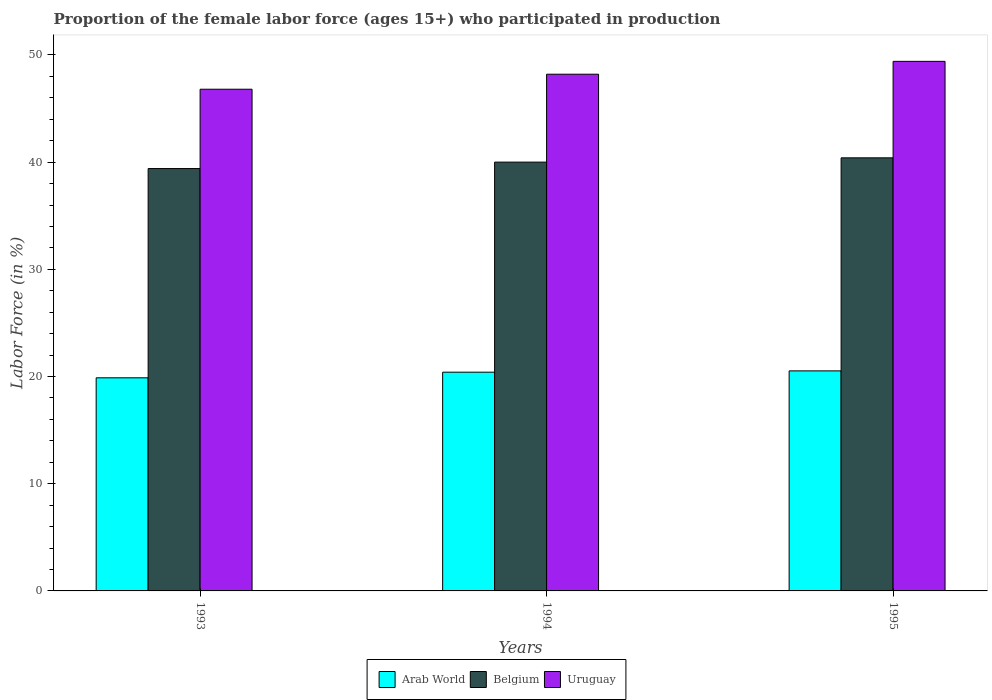Are the number of bars on each tick of the X-axis equal?
Provide a succinct answer. Yes. How many bars are there on the 2nd tick from the right?
Your response must be concise. 3. What is the proportion of the female labor force who participated in production in Uruguay in 1993?
Offer a terse response. 46.8. Across all years, what is the maximum proportion of the female labor force who participated in production in Uruguay?
Give a very brief answer. 49.4. Across all years, what is the minimum proportion of the female labor force who participated in production in Belgium?
Make the answer very short. 39.4. In which year was the proportion of the female labor force who participated in production in Belgium maximum?
Your response must be concise. 1995. In which year was the proportion of the female labor force who participated in production in Arab World minimum?
Offer a very short reply. 1993. What is the total proportion of the female labor force who participated in production in Arab World in the graph?
Your answer should be compact. 60.81. What is the difference between the proportion of the female labor force who participated in production in Arab World in 1994 and that in 1995?
Provide a succinct answer. -0.12. What is the difference between the proportion of the female labor force who participated in production in Arab World in 1993 and the proportion of the female labor force who participated in production in Belgium in 1994?
Provide a short and direct response. -20.12. What is the average proportion of the female labor force who participated in production in Arab World per year?
Provide a short and direct response. 20.27. In the year 1993, what is the difference between the proportion of the female labor force who participated in production in Uruguay and proportion of the female labor force who participated in production in Belgium?
Give a very brief answer. 7.4. In how many years, is the proportion of the female labor force who participated in production in Belgium greater than 48 %?
Provide a short and direct response. 0. What is the ratio of the proportion of the female labor force who participated in production in Arab World in 1994 to that in 1995?
Provide a short and direct response. 0.99. Is the proportion of the female labor force who participated in production in Arab World in 1993 less than that in 1994?
Offer a very short reply. Yes. What is the difference between the highest and the second highest proportion of the female labor force who participated in production in Belgium?
Make the answer very short. 0.4. What is the difference between the highest and the lowest proportion of the female labor force who participated in production in Uruguay?
Make the answer very short. 2.6. Is the sum of the proportion of the female labor force who participated in production in Belgium in 1994 and 1995 greater than the maximum proportion of the female labor force who participated in production in Arab World across all years?
Make the answer very short. Yes. What does the 3rd bar from the left in 1994 represents?
Your response must be concise. Uruguay. What does the 3rd bar from the right in 1995 represents?
Offer a very short reply. Arab World. Is it the case that in every year, the sum of the proportion of the female labor force who participated in production in Uruguay and proportion of the female labor force who participated in production in Arab World is greater than the proportion of the female labor force who participated in production in Belgium?
Keep it short and to the point. Yes. Are all the bars in the graph horizontal?
Your response must be concise. No. How many years are there in the graph?
Your answer should be very brief. 3. Are the values on the major ticks of Y-axis written in scientific E-notation?
Provide a succinct answer. No. Does the graph contain any zero values?
Provide a succinct answer. No. Does the graph contain grids?
Keep it short and to the point. No. How many legend labels are there?
Your answer should be compact. 3. How are the legend labels stacked?
Offer a very short reply. Horizontal. What is the title of the graph?
Keep it short and to the point. Proportion of the female labor force (ages 15+) who participated in production. Does "Sri Lanka" appear as one of the legend labels in the graph?
Offer a very short reply. No. What is the label or title of the X-axis?
Offer a very short reply. Years. What is the Labor Force (in %) of Arab World in 1993?
Keep it short and to the point. 19.88. What is the Labor Force (in %) of Belgium in 1993?
Your response must be concise. 39.4. What is the Labor Force (in %) in Uruguay in 1993?
Your answer should be very brief. 46.8. What is the Labor Force (in %) in Arab World in 1994?
Your response must be concise. 20.41. What is the Labor Force (in %) of Uruguay in 1994?
Your answer should be compact. 48.2. What is the Labor Force (in %) of Arab World in 1995?
Make the answer very short. 20.53. What is the Labor Force (in %) in Belgium in 1995?
Your answer should be very brief. 40.4. What is the Labor Force (in %) in Uruguay in 1995?
Your answer should be compact. 49.4. Across all years, what is the maximum Labor Force (in %) of Arab World?
Provide a succinct answer. 20.53. Across all years, what is the maximum Labor Force (in %) in Belgium?
Your answer should be compact. 40.4. Across all years, what is the maximum Labor Force (in %) in Uruguay?
Your answer should be very brief. 49.4. Across all years, what is the minimum Labor Force (in %) in Arab World?
Provide a short and direct response. 19.88. Across all years, what is the minimum Labor Force (in %) of Belgium?
Offer a very short reply. 39.4. Across all years, what is the minimum Labor Force (in %) of Uruguay?
Your answer should be very brief. 46.8. What is the total Labor Force (in %) in Arab World in the graph?
Ensure brevity in your answer.  60.81. What is the total Labor Force (in %) of Belgium in the graph?
Provide a succinct answer. 119.8. What is the total Labor Force (in %) of Uruguay in the graph?
Your answer should be compact. 144.4. What is the difference between the Labor Force (in %) in Arab World in 1993 and that in 1994?
Offer a very short reply. -0.53. What is the difference between the Labor Force (in %) of Uruguay in 1993 and that in 1994?
Ensure brevity in your answer.  -1.4. What is the difference between the Labor Force (in %) in Arab World in 1993 and that in 1995?
Provide a succinct answer. -0.65. What is the difference between the Labor Force (in %) of Arab World in 1994 and that in 1995?
Give a very brief answer. -0.12. What is the difference between the Labor Force (in %) in Belgium in 1994 and that in 1995?
Ensure brevity in your answer.  -0.4. What is the difference between the Labor Force (in %) in Uruguay in 1994 and that in 1995?
Keep it short and to the point. -1.2. What is the difference between the Labor Force (in %) in Arab World in 1993 and the Labor Force (in %) in Belgium in 1994?
Provide a succinct answer. -20.12. What is the difference between the Labor Force (in %) of Arab World in 1993 and the Labor Force (in %) of Uruguay in 1994?
Offer a very short reply. -28.32. What is the difference between the Labor Force (in %) of Belgium in 1993 and the Labor Force (in %) of Uruguay in 1994?
Provide a short and direct response. -8.8. What is the difference between the Labor Force (in %) of Arab World in 1993 and the Labor Force (in %) of Belgium in 1995?
Your answer should be very brief. -20.52. What is the difference between the Labor Force (in %) of Arab World in 1993 and the Labor Force (in %) of Uruguay in 1995?
Ensure brevity in your answer.  -29.52. What is the difference between the Labor Force (in %) of Arab World in 1994 and the Labor Force (in %) of Belgium in 1995?
Give a very brief answer. -19.99. What is the difference between the Labor Force (in %) of Arab World in 1994 and the Labor Force (in %) of Uruguay in 1995?
Your response must be concise. -28.99. What is the average Labor Force (in %) in Arab World per year?
Give a very brief answer. 20.27. What is the average Labor Force (in %) in Belgium per year?
Provide a succinct answer. 39.93. What is the average Labor Force (in %) in Uruguay per year?
Provide a short and direct response. 48.13. In the year 1993, what is the difference between the Labor Force (in %) in Arab World and Labor Force (in %) in Belgium?
Your response must be concise. -19.52. In the year 1993, what is the difference between the Labor Force (in %) in Arab World and Labor Force (in %) in Uruguay?
Provide a succinct answer. -26.92. In the year 1993, what is the difference between the Labor Force (in %) of Belgium and Labor Force (in %) of Uruguay?
Your answer should be compact. -7.4. In the year 1994, what is the difference between the Labor Force (in %) in Arab World and Labor Force (in %) in Belgium?
Your response must be concise. -19.59. In the year 1994, what is the difference between the Labor Force (in %) of Arab World and Labor Force (in %) of Uruguay?
Keep it short and to the point. -27.79. In the year 1994, what is the difference between the Labor Force (in %) of Belgium and Labor Force (in %) of Uruguay?
Your answer should be compact. -8.2. In the year 1995, what is the difference between the Labor Force (in %) of Arab World and Labor Force (in %) of Belgium?
Your response must be concise. -19.87. In the year 1995, what is the difference between the Labor Force (in %) of Arab World and Labor Force (in %) of Uruguay?
Give a very brief answer. -28.87. In the year 1995, what is the difference between the Labor Force (in %) in Belgium and Labor Force (in %) in Uruguay?
Your response must be concise. -9. What is the ratio of the Labor Force (in %) in Arab World in 1993 to that in 1994?
Your answer should be very brief. 0.97. What is the ratio of the Labor Force (in %) in Belgium in 1993 to that in 1994?
Offer a very short reply. 0.98. What is the ratio of the Labor Force (in %) in Uruguay in 1993 to that in 1994?
Your response must be concise. 0.97. What is the ratio of the Labor Force (in %) of Arab World in 1993 to that in 1995?
Your answer should be compact. 0.97. What is the ratio of the Labor Force (in %) of Belgium in 1993 to that in 1995?
Your answer should be very brief. 0.98. What is the ratio of the Labor Force (in %) in Uruguay in 1993 to that in 1995?
Provide a short and direct response. 0.95. What is the ratio of the Labor Force (in %) in Arab World in 1994 to that in 1995?
Your answer should be compact. 0.99. What is the ratio of the Labor Force (in %) of Belgium in 1994 to that in 1995?
Your response must be concise. 0.99. What is the ratio of the Labor Force (in %) in Uruguay in 1994 to that in 1995?
Your response must be concise. 0.98. What is the difference between the highest and the second highest Labor Force (in %) of Arab World?
Offer a terse response. 0.12. What is the difference between the highest and the second highest Labor Force (in %) in Belgium?
Keep it short and to the point. 0.4. What is the difference between the highest and the second highest Labor Force (in %) of Uruguay?
Your answer should be compact. 1.2. What is the difference between the highest and the lowest Labor Force (in %) in Arab World?
Offer a terse response. 0.65. What is the difference between the highest and the lowest Labor Force (in %) in Belgium?
Your answer should be compact. 1. 